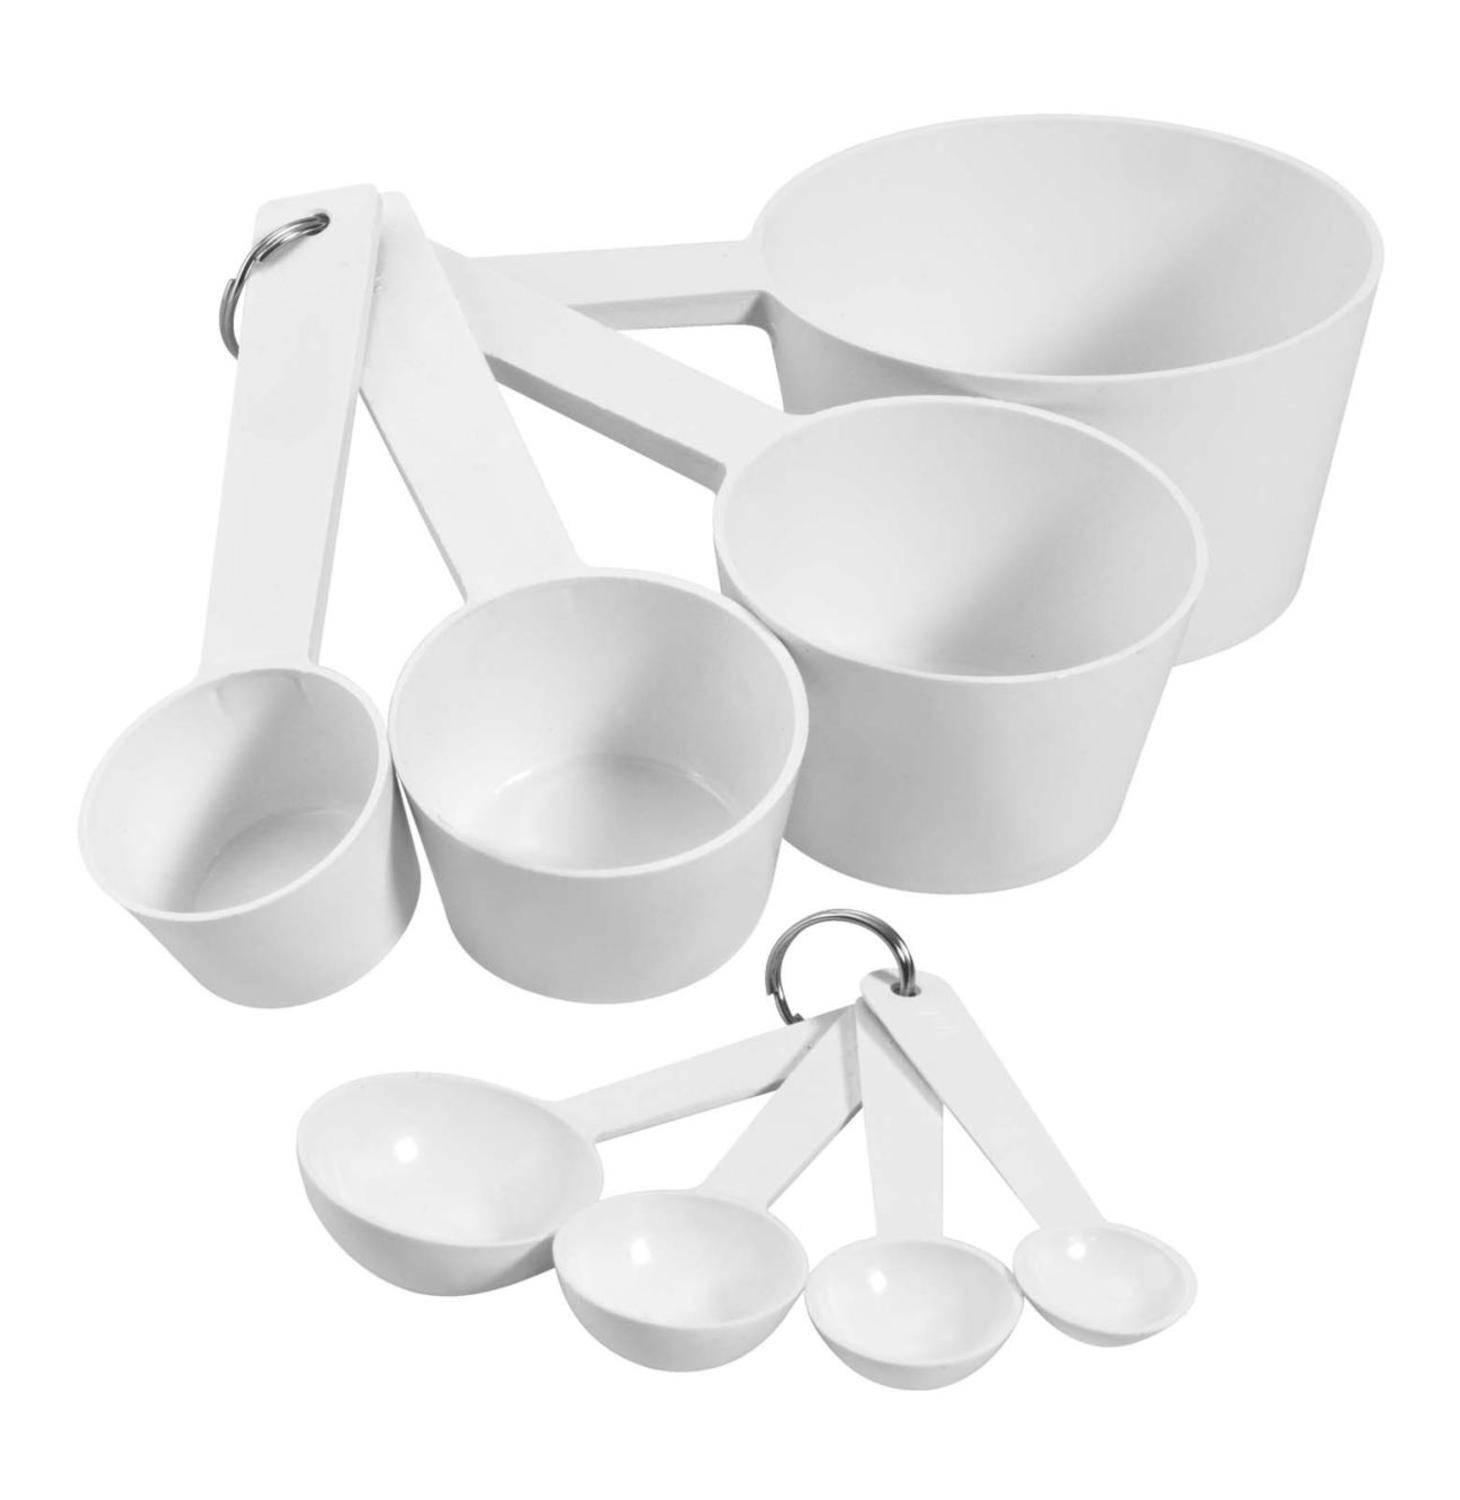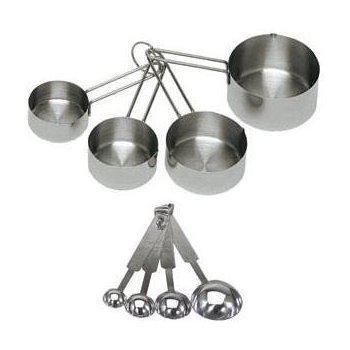The first image is the image on the left, the second image is the image on the right. Examine the images to the left and right. Is the description "The right image shows only one set of measuring utensils joined together." accurate? Answer yes or no. No. 